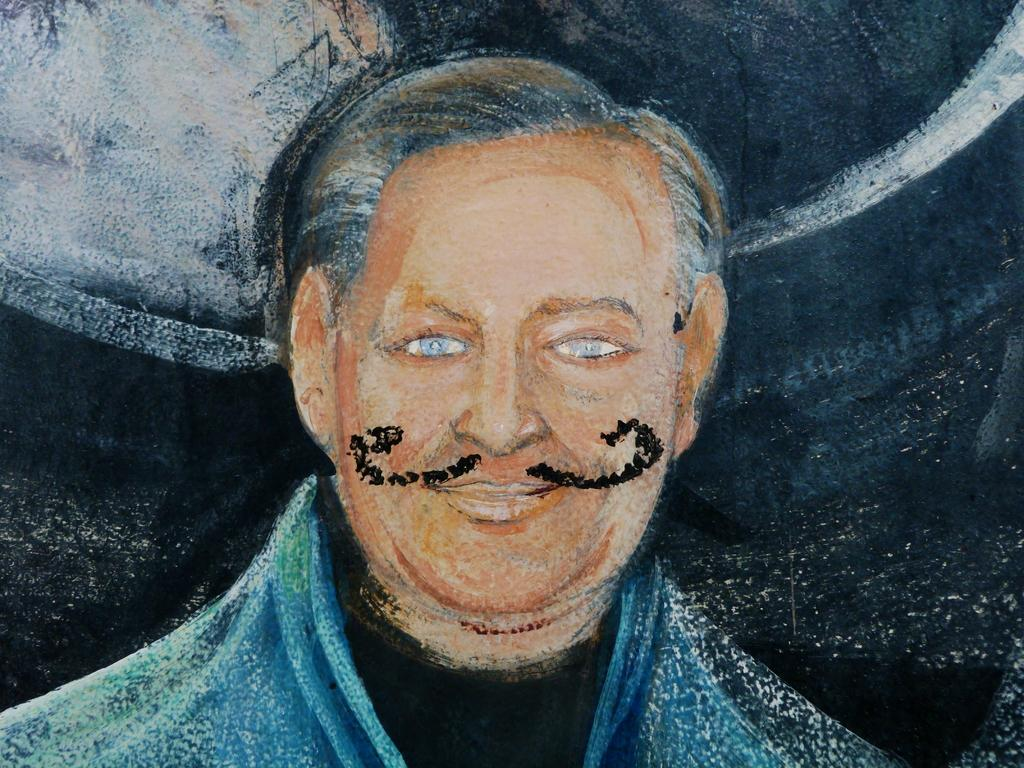What is the main subject of the image? There is a painting in the image. What does the painting depict? The painting depicts a person. Can you describe the person in the painting? The person in the painting has a mustache. What type of education does the person in the painting have? The image does not provide any information about the person's education, as it only shows a painting of the person with a mustache. 